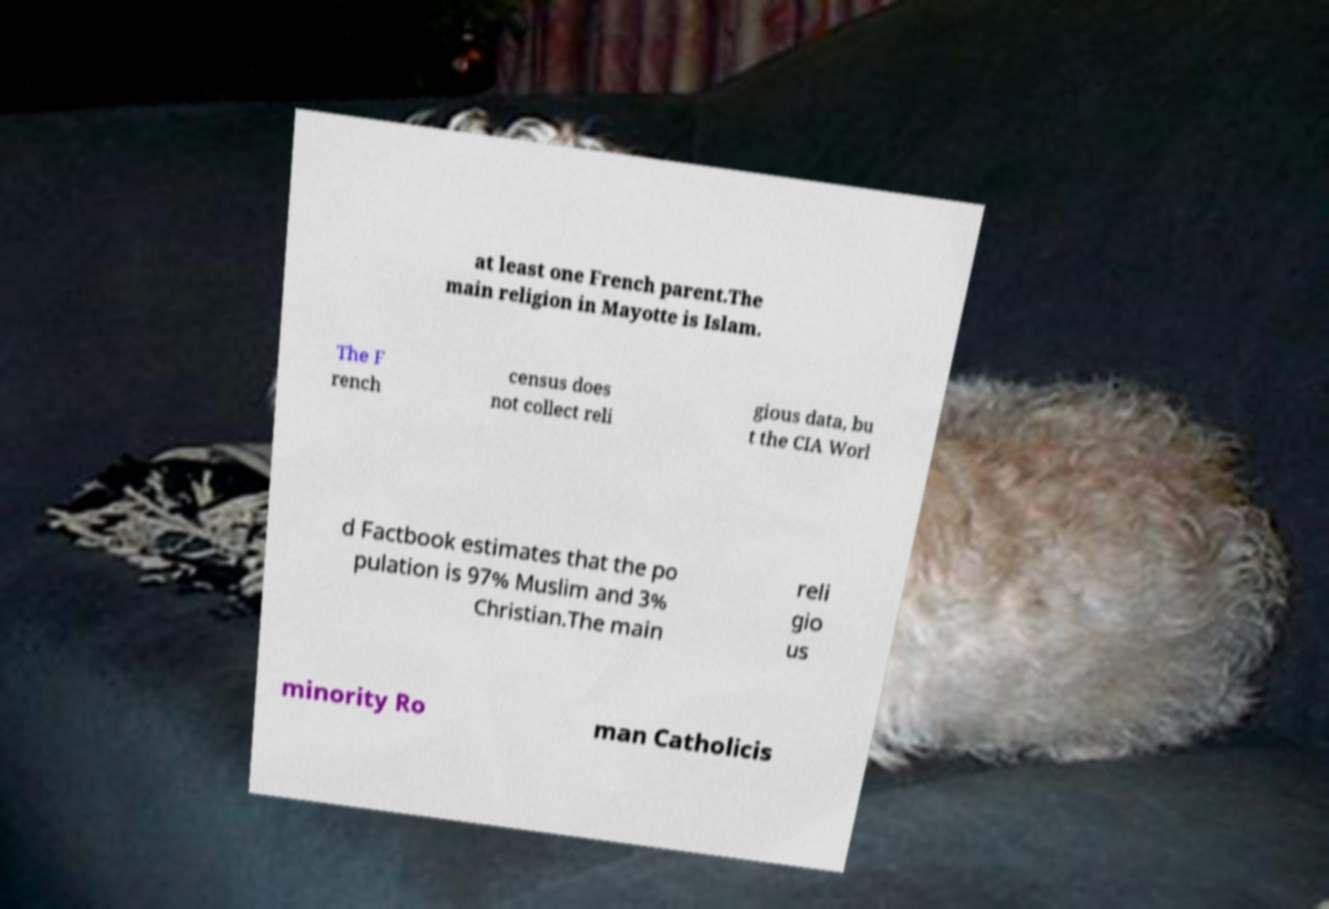Could you assist in decoding the text presented in this image and type it out clearly? at least one French parent.The main religion in Mayotte is Islam. The F rench census does not collect reli gious data, bu t the CIA Worl d Factbook estimates that the po pulation is 97% Muslim and 3% Christian.The main reli gio us minority Ro man Catholicis 